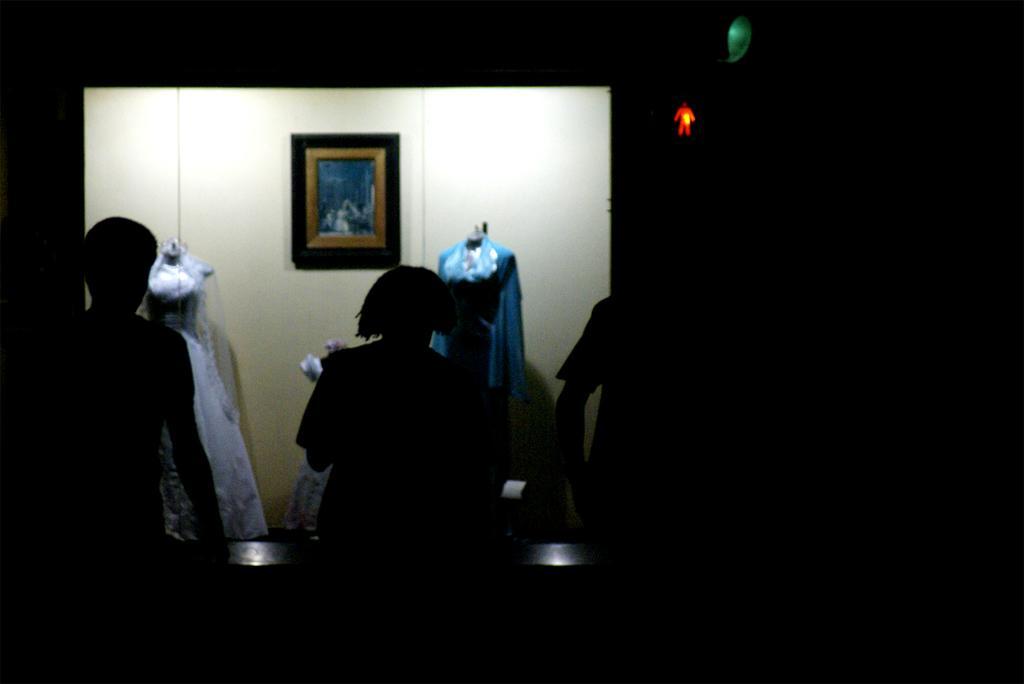Can you describe this image briefly? In this image there are persons standing in the center. In the background there are statues and there is a frame on the wall. On the right side there are lights which are red and green in colour. 